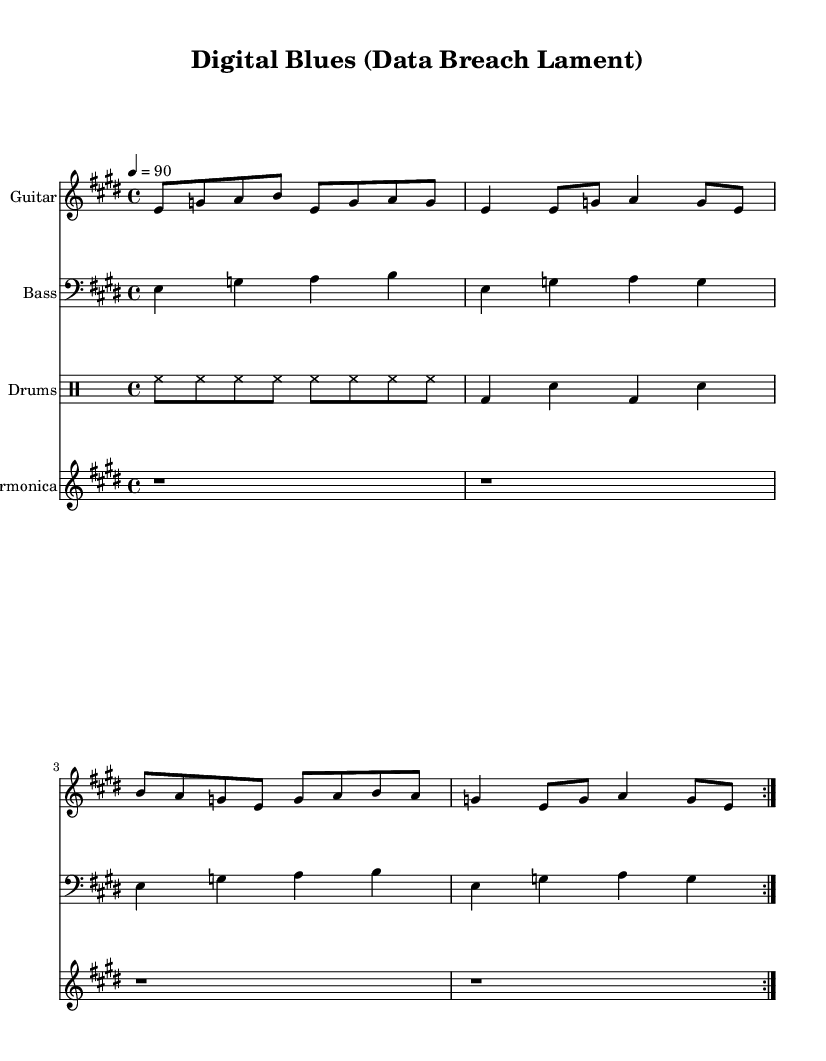What is the key signature of this music? The key signature is E major, which has four sharps (F#, C#, G#, and D#). This can be determined by looking at the key signature that appears at the beginning of the staff.
Answer: E major What is the time signature of this piece? The time signature is four-four, which can be identified from the '4/4' notation at the beginning of the piece. This tells us there are four beats in each measure.
Answer: 4/4 What is the tempo marking of this music? The tempo marking is "4 = 90", indicating that there are 90 quarter note beats per minute. This can be understood by reading the tempo indication that appears in the header section of the sheet music.
Answer: 90 How many measures are in the guitar part? The guitar part consists of 8 measures, which can be counted by looking at the repeated sections indicated by the volta marks and counting the measures within the repeat. Each measure contains musical notes and rests, and the entire section is repeated twice.
Answer: 8 What style of music does this piece represent? This piece represents Electric Blues, as indicated in the title and thematic content of the lyrics, which focus on data privacy and cybersecurity challenges, typical of the Electric Blues genre.
Answer: Electric Blues Which instruments are included in this score? The instruments included in this score are Guitar, Bass, Drums, and Harmonica. This can be identified by inspecting the staves at the beginning of the score, where each instrument is listed.
Answer: Guitar, Bass, Drums, Harmonica What is the primary theme depicted in the lyrics? The primary theme depicted in the lyrics is data breaches and cybersecurity fears, highlighting the challenges associated with digital security in modern times. This can be recognized by analyzing the content of the lyrics written under the musical notation.
Answer: Data breaches 